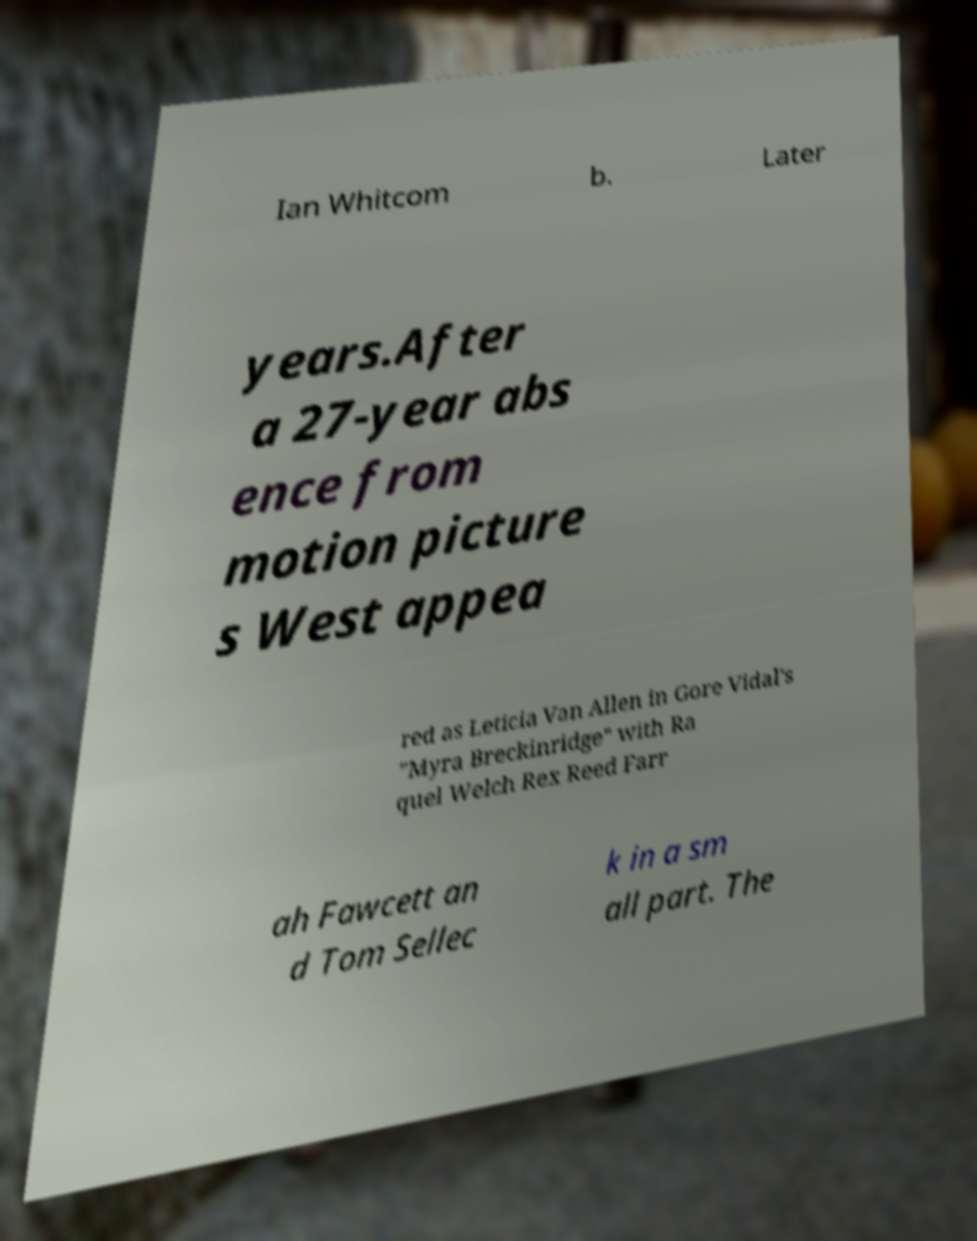Please identify and transcribe the text found in this image. Ian Whitcom b. Later years.After a 27-year abs ence from motion picture s West appea red as Leticia Van Allen in Gore Vidal's "Myra Breckinridge" with Ra quel Welch Rex Reed Farr ah Fawcett an d Tom Sellec k in a sm all part. The 